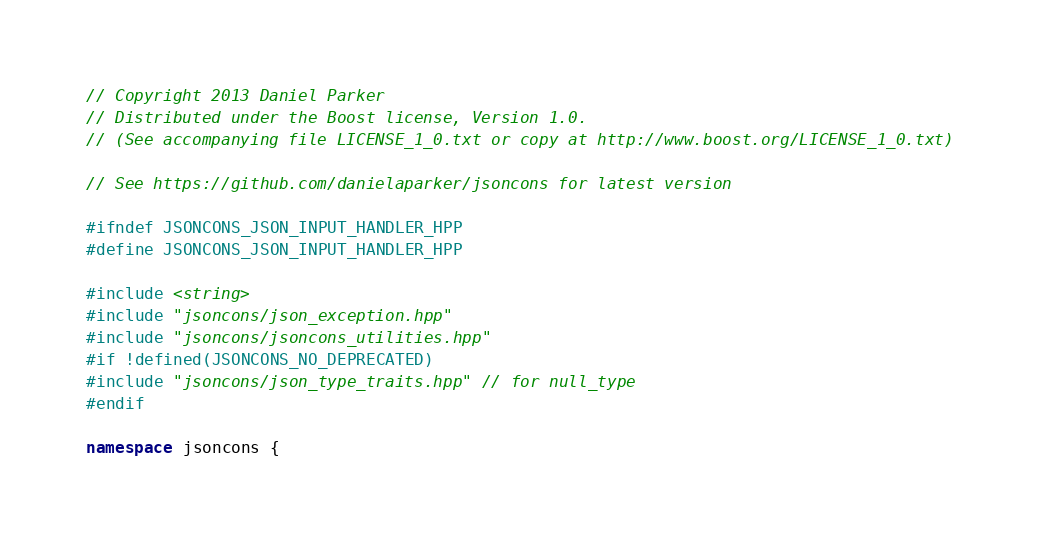Convert code to text. <code><loc_0><loc_0><loc_500><loc_500><_C++_>// Copyright 2013 Daniel Parker
// Distributed under the Boost license, Version 1.0.
// (See accompanying file LICENSE_1_0.txt or copy at http://www.boost.org/LICENSE_1_0.txt)

// See https://github.com/danielaparker/jsoncons for latest version

#ifndef JSONCONS_JSON_INPUT_HANDLER_HPP
#define JSONCONS_JSON_INPUT_HANDLER_HPP

#include <string>
#include "jsoncons/json_exception.hpp"
#include "jsoncons/jsoncons_utilities.hpp"
#if !defined(JSONCONS_NO_DEPRECATED)
#include "jsoncons/json_type_traits.hpp" // for null_type
#endif

namespace jsoncons {
</code> 